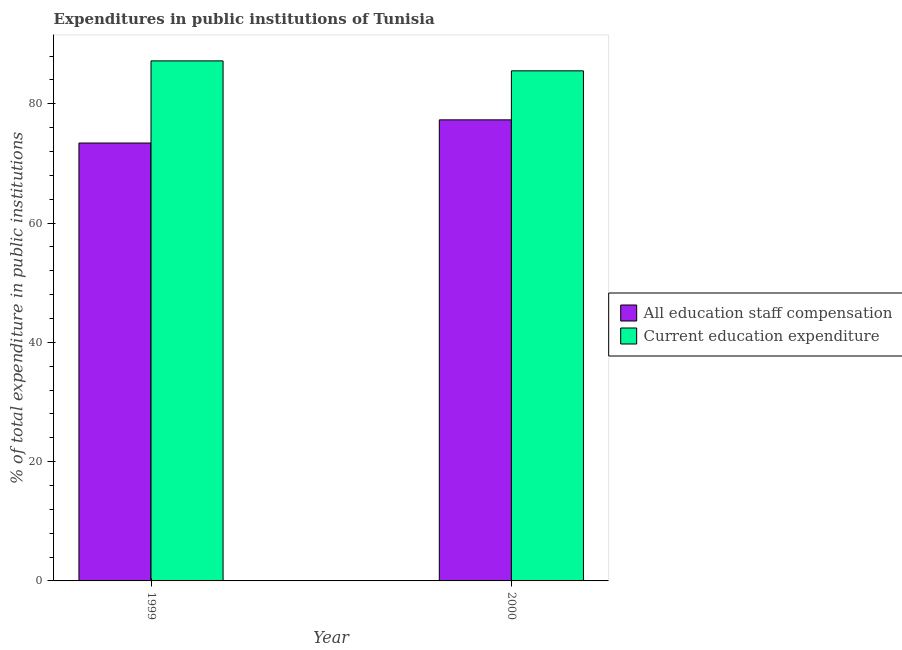Are the number of bars per tick equal to the number of legend labels?
Ensure brevity in your answer.  Yes. How many bars are there on the 1st tick from the left?
Keep it short and to the point. 2. What is the label of the 2nd group of bars from the left?
Make the answer very short. 2000. What is the expenditure in staff compensation in 2000?
Offer a terse response. 77.3. Across all years, what is the maximum expenditure in staff compensation?
Your response must be concise. 77.3. Across all years, what is the minimum expenditure in staff compensation?
Offer a terse response. 73.41. In which year was the expenditure in staff compensation maximum?
Keep it short and to the point. 2000. What is the total expenditure in education in the graph?
Keep it short and to the point. 172.7. What is the difference between the expenditure in staff compensation in 1999 and that in 2000?
Your answer should be very brief. -3.88. What is the difference between the expenditure in staff compensation in 2000 and the expenditure in education in 1999?
Provide a succinct answer. 3.88. What is the average expenditure in staff compensation per year?
Your answer should be very brief. 75.35. In how many years, is the expenditure in education greater than 40 %?
Your answer should be compact. 2. What is the ratio of the expenditure in education in 1999 to that in 2000?
Offer a very short reply. 1.02. Is the expenditure in education in 1999 less than that in 2000?
Provide a succinct answer. No. In how many years, is the expenditure in education greater than the average expenditure in education taken over all years?
Keep it short and to the point. 1. What does the 1st bar from the left in 2000 represents?
Offer a very short reply. All education staff compensation. What does the 1st bar from the right in 1999 represents?
Give a very brief answer. Current education expenditure. Are all the bars in the graph horizontal?
Provide a short and direct response. No. How many years are there in the graph?
Your answer should be compact. 2. Are the values on the major ticks of Y-axis written in scientific E-notation?
Provide a short and direct response. No. Does the graph contain any zero values?
Your answer should be very brief. No. Does the graph contain grids?
Provide a succinct answer. No. Where does the legend appear in the graph?
Give a very brief answer. Center right. What is the title of the graph?
Provide a short and direct response. Expenditures in public institutions of Tunisia. Does "Study and work" appear as one of the legend labels in the graph?
Your answer should be very brief. No. What is the label or title of the X-axis?
Give a very brief answer. Year. What is the label or title of the Y-axis?
Make the answer very short. % of total expenditure in public institutions. What is the % of total expenditure in public institutions in All education staff compensation in 1999?
Ensure brevity in your answer.  73.41. What is the % of total expenditure in public institutions in Current education expenditure in 1999?
Your answer should be compact. 87.18. What is the % of total expenditure in public institutions of All education staff compensation in 2000?
Your answer should be compact. 77.3. What is the % of total expenditure in public institutions of Current education expenditure in 2000?
Your answer should be very brief. 85.51. Across all years, what is the maximum % of total expenditure in public institutions of All education staff compensation?
Provide a succinct answer. 77.3. Across all years, what is the maximum % of total expenditure in public institutions of Current education expenditure?
Provide a succinct answer. 87.18. Across all years, what is the minimum % of total expenditure in public institutions in All education staff compensation?
Give a very brief answer. 73.41. Across all years, what is the minimum % of total expenditure in public institutions in Current education expenditure?
Keep it short and to the point. 85.51. What is the total % of total expenditure in public institutions in All education staff compensation in the graph?
Your answer should be compact. 150.71. What is the total % of total expenditure in public institutions in Current education expenditure in the graph?
Give a very brief answer. 172.7. What is the difference between the % of total expenditure in public institutions of All education staff compensation in 1999 and that in 2000?
Provide a short and direct response. -3.88. What is the difference between the % of total expenditure in public institutions in Current education expenditure in 1999 and that in 2000?
Give a very brief answer. 1.67. What is the difference between the % of total expenditure in public institutions in All education staff compensation in 1999 and the % of total expenditure in public institutions in Current education expenditure in 2000?
Keep it short and to the point. -12.1. What is the average % of total expenditure in public institutions in All education staff compensation per year?
Ensure brevity in your answer.  75.35. What is the average % of total expenditure in public institutions in Current education expenditure per year?
Make the answer very short. 86.35. In the year 1999, what is the difference between the % of total expenditure in public institutions in All education staff compensation and % of total expenditure in public institutions in Current education expenditure?
Provide a short and direct response. -13.77. In the year 2000, what is the difference between the % of total expenditure in public institutions in All education staff compensation and % of total expenditure in public institutions in Current education expenditure?
Your answer should be very brief. -8.22. What is the ratio of the % of total expenditure in public institutions of All education staff compensation in 1999 to that in 2000?
Provide a short and direct response. 0.95. What is the ratio of the % of total expenditure in public institutions of Current education expenditure in 1999 to that in 2000?
Offer a terse response. 1.02. What is the difference between the highest and the second highest % of total expenditure in public institutions of All education staff compensation?
Keep it short and to the point. 3.88. What is the difference between the highest and the second highest % of total expenditure in public institutions in Current education expenditure?
Give a very brief answer. 1.67. What is the difference between the highest and the lowest % of total expenditure in public institutions in All education staff compensation?
Make the answer very short. 3.88. What is the difference between the highest and the lowest % of total expenditure in public institutions of Current education expenditure?
Offer a terse response. 1.67. 